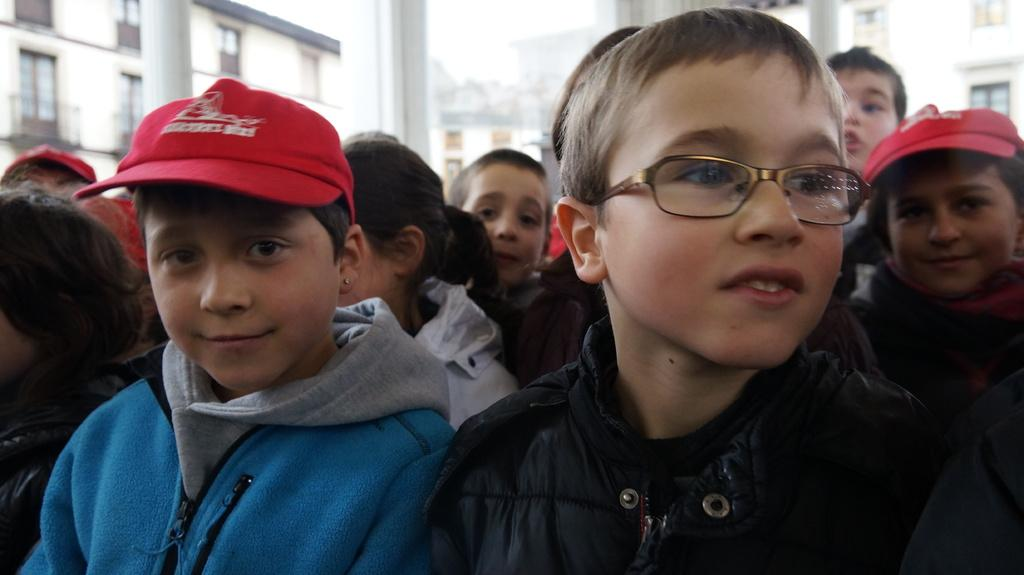How many people are in the image? There is a group of people in the image, but the exact number is not specified. What are some of the people wearing? Some of the people in the image are wearing caps. What type of structures can be seen in the image? There are buildings in the image. What else can be seen in the image besides the people and buildings? There are poles in the image. What is visible in the background of the image? The sky is visible in the image. Can you tell me how many cherries are on the maid's hat in the image? There is no maid or cherry present in the image. What type of bell can be heard ringing in the image? There is no bell present in the image, and therefore no sound can be heard. 